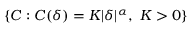Convert formula to latex. <formula><loc_0><loc_0><loc_500><loc_500>\{ C \colon C ( \delta ) = K | \delta | ^ { \alpha } , \ K > 0 \}</formula> 